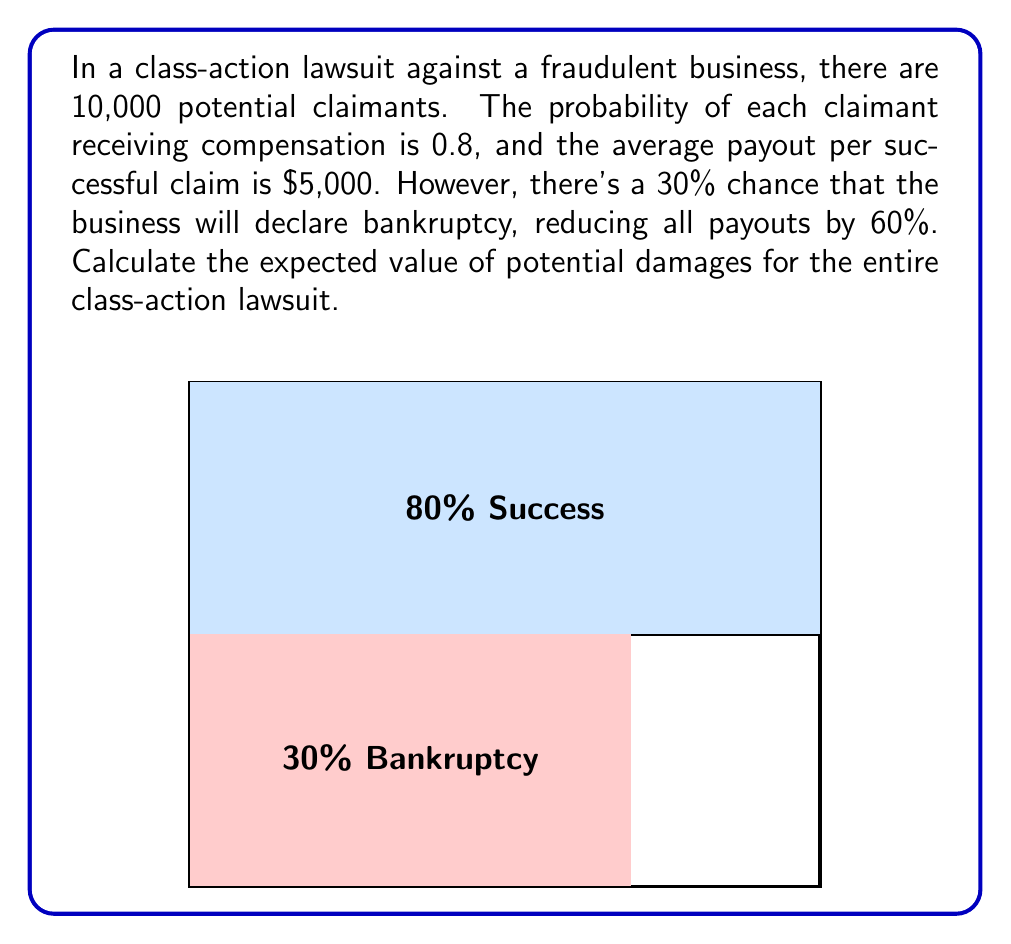Can you solve this math problem? Let's break this down step-by-step:

1) First, calculate the expected payout for a single claimant without considering bankruptcy:
   $$E(\text{single claim}) = 0.8 \times \$5,000 = \$4,000$$

2) Now, consider the bankruptcy scenario:
   - 70% chance of full payout: $0.7 \times \$4,000 = \$2,800$
   - 30% chance of reduced payout: $0.3 \times (0.4 \times \$4,000) = \$480$

3) The expected value for a single claim, considering bankruptcy:
   $$E(\text{adjusted claim}) = \$2,800 + \$480 = \$3,280$$

4) For all 10,000 claimants:
   $$E(\text{total damages}) = 10,000 \times \$3,280 = \$32,800,000$$

Thus, the expected value of potential damages for the entire class-action lawsuit is $32,800,000.
Answer: $32,800,000 